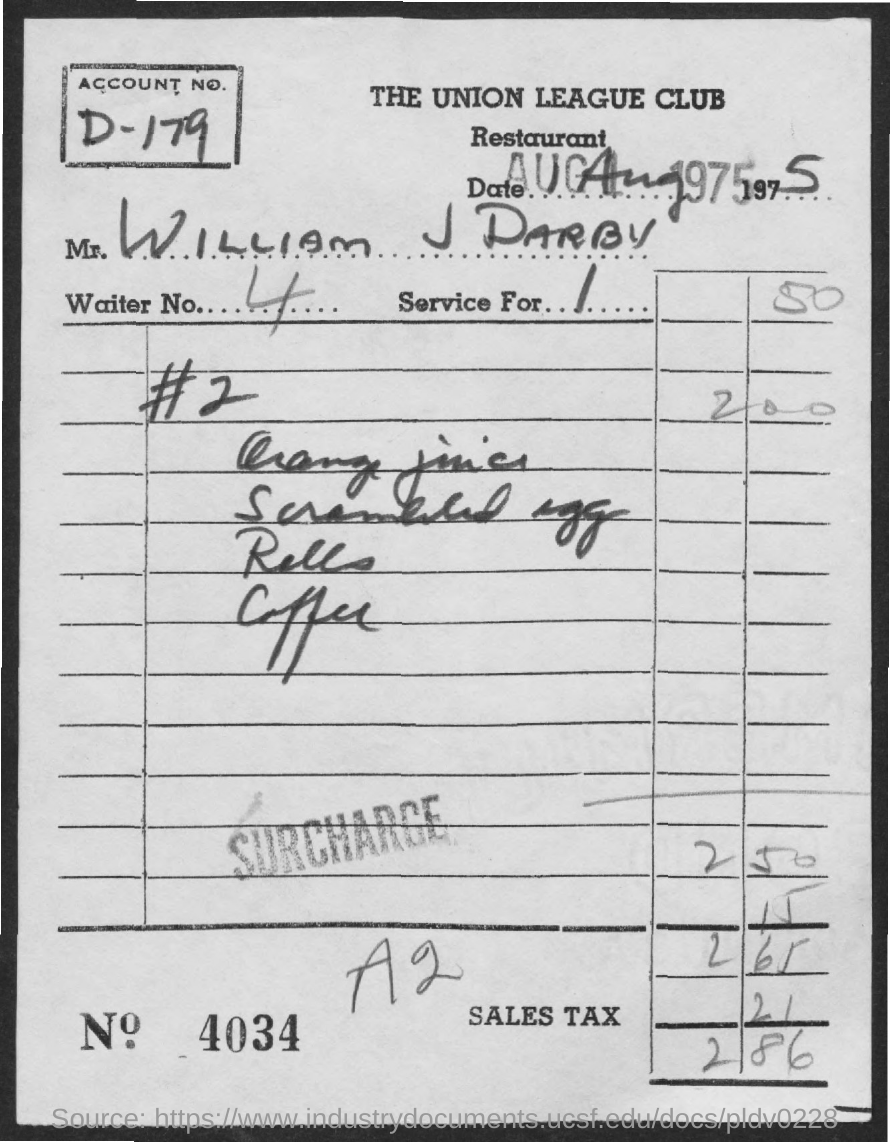What is the Account No. given in the bill?
Your response must be concise. D-179. What is the name of the person given in the bill?
Keep it short and to the point. WILLIAM J DARBY. What is the Waiter No. given in the bill?
Your answer should be very brief. 4. 